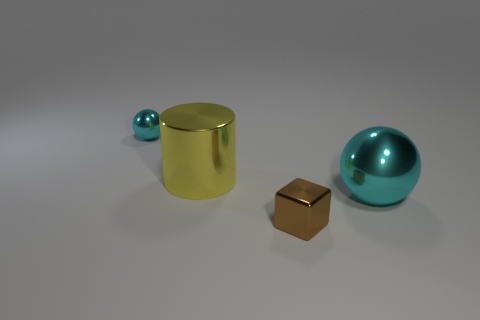Is the tiny metal sphere the same color as the shiny block? No, they are not the same color. The tiny sphere appears to have a turquoise hue, while the shiny block has a golden tone. 